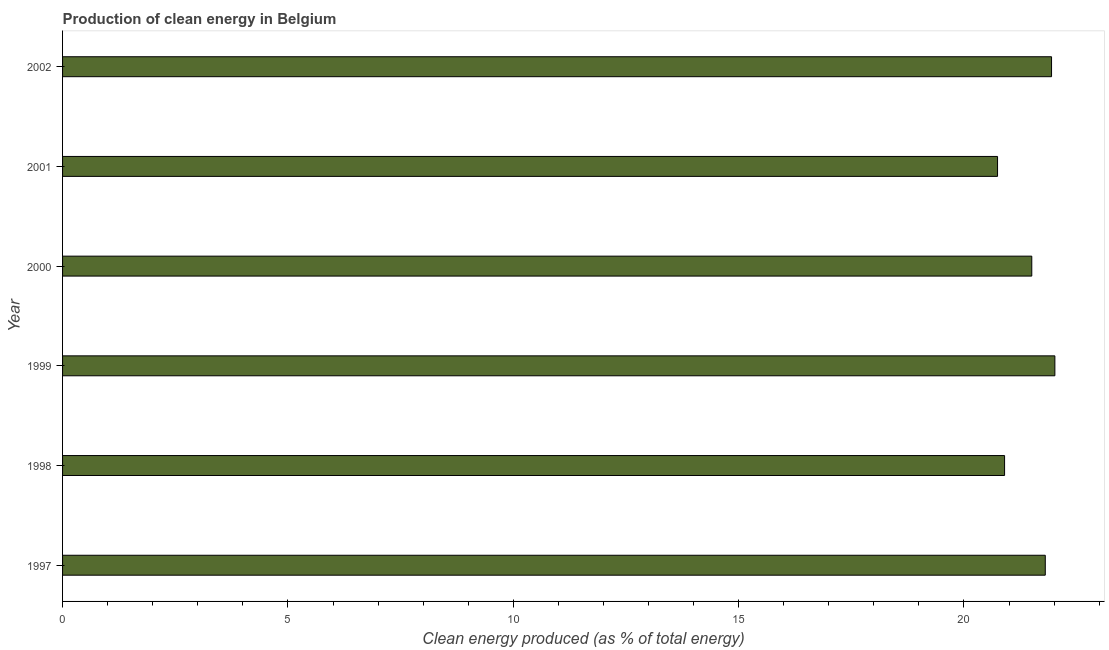Does the graph contain any zero values?
Keep it short and to the point. No. What is the title of the graph?
Offer a terse response. Production of clean energy in Belgium. What is the label or title of the X-axis?
Your response must be concise. Clean energy produced (as % of total energy). What is the production of clean energy in 1999?
Keep it short and to the point. 22.02. Across all years, what is the maximum production of clean energy?
Make the answer very short. 22.02. Across all years, what is the minimum production of clean energy?
Offer a terse response. 20.74. In which year was the production of clean energy minimum?
Give a very brief answer. 2001. What is the sum of the production of clean energy?
Ensure brevity in your answer.  128.91. What is the difference between the production of clean energy in 1997 and 2000?
Offer a terse response. 0.3. What is the average production of clean energy per year?
Your answer should be compact. 21.48. What is the median production of clean energy?
Make the answer very short. 21.65. Do a majority of the years between 1998 and 2001 (inclusive) have production of clean energy greater than 6 %?
Your answer should be very brief. Yes. What is the ratio of the production of clean energy in 2000 to that in 2002?
Give a very brief answer. 0.98. What is the difference between the highest and the second highest production of clean energy?
Your response must be concise. 0.07. What is the difference between the highest and the lowest production of clean energy?
Your answer should be compact. 1.27. How many bars are there?
Provide a short and direct response. 6. Are all the bars in the graph horizontal?
Your response must be concise. Yes. Are the values on the major ticks of X-axis written in scientific E-notation?
Offer a terse response. No. What is the Clean energy produced (as % of total energy) of 1997?
Offer a very short reply. 21.8. What is the Clean energy produced (as % of total energy) of 1998?
Ensure brevity in your answer.  20.9. What is the Clean energy produced (as % of total energy) in 1999?
Give a very brief answer. 22.02. What is the Clean energy produced (as % of total energy) in 2000?
Give a very brief answer. 21.5. What is the Clean energy produced (as % of total energy) of 2001?
Your answer should be compact. 20.74. What is the Clean energy produced (as % of total energy) of 2002?
Offer a terse response. 21.94. What is the difference between the Clean energy produced (as % of total energy) in 1997 and 1998?
Provide a short and direct response. 0.9. What is the difference between the Clean energy produced (as % of total energy) in 1997 and 1999?
Provide a short and direct response. -0.21. What is the difference between the Clean energy produced (as % of total energy) in 1997 and 2000?
Keep it short and to the point. 0.3. What is the difference between the Clean energy produced (as % of total energy) in 1997 and 2001?
Your response must be concise. 1.06. What is the difference between the Clean energy produced (as % of total energy) in 1997 and 2002?
Offer a very short reply. -0.14. What is the difference between the Clean energy produced (as % of total energy) in 1998 and 1999?
Provide a succinct answer. -1.12. What is the difference between the Clean energy produced (as % of total energy) in 1998 and 2000?
Provide a succinct answer. -0.6. What is the difference between the Clean energy produced (as % of total energy) in 1998 and 2001?
Your response must be concise. 0.16. What is the difference between the Clean energy produced (as % of total energy) in 1998 and 2002?
Keep it short and to the point. -1.04. What is the difference between the Clean energy produced (as % of total energy) in 1999 and 2000?
Provide a succinct answer. 0.51. What is the difference between the Clean energy produced (as % of total energy) in 1999 and 2001?
Offer a terse response. 1.27. What is the difference between the Clean energy produced (as % of total energy) in 1999 and 2002?
Ensure brevity in your answer.  0.07. What is the difference between the Clean energy produced (as % of total energy) in 2000 and 2001?
Provide a succinct answer. 0.76. What is the difference between the Clean energy produced (as % of total energy) in 2000 and 2002?
Your answer should be compact. -0.44. What is the difference between the Clean energy produced (as % of total energy) in 2001 and 2002?
Provide a succinct answer. -1.2. What is the ratio of the Clean energy produced (as % of total energy) in 1997 to that in 1998?
Make the answer very short. 1.04. What is the ratio of the Clean energy produced (as % of total energy) in 1997 to that in 1999?
Give a very brief answer. 0.99. What is the ratio of the Clean energy produced (as % of total energy) in 1997 to that in 2001?
Your response must be concise. 1.05. What is the ratio of the Clean energy produced (as % of total energy) in 1998 to that in 1999?
Make the answer very short. 0.95. What is the ratio of the Clean energy produced (as % of total energy) in 1999 to that in 2001?
Your answer should be compact. 1.06. What is the ratio of the Clean energy produced (as % of total energy) in 2000 to that in 2001?
Provide a succinct answer. 1.04. What is the ratio of the Clean energy produced (as % of total energy) in 2001 to that in 2002?
Your response must be concise. 0.94. 